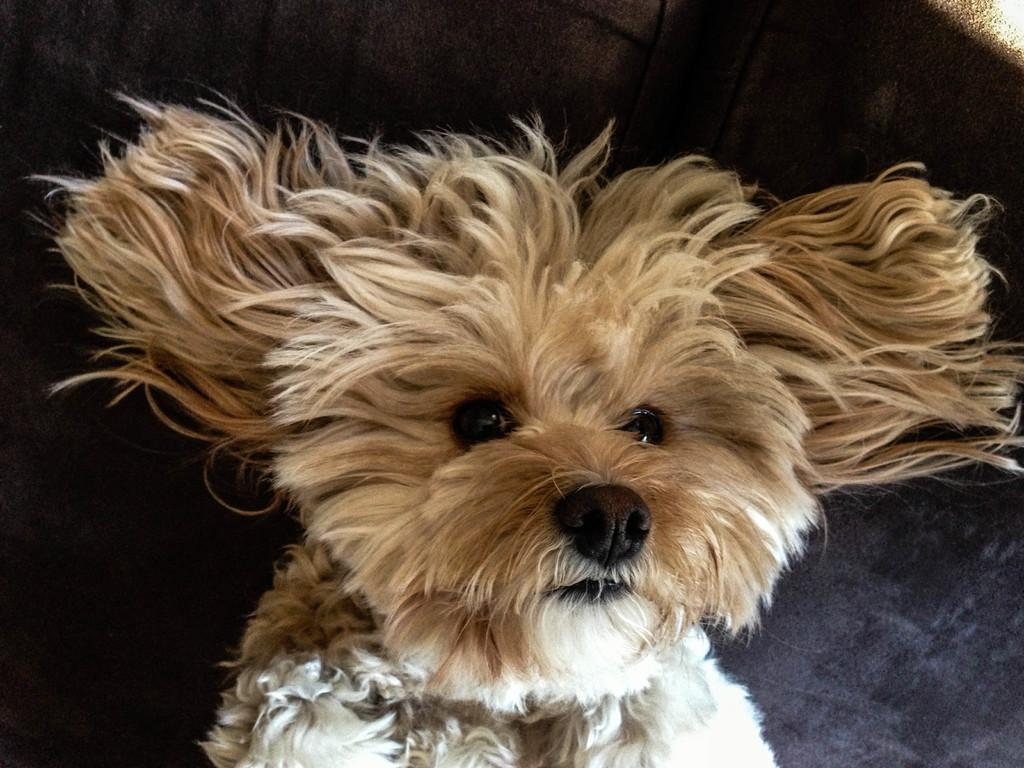What animal is present in the image? There is a dog in the picture. What color is the background of the image? The background of the image is black in color. Can you describe the grey area in the image? There is a grey area in the right bottom of the picture. What type of plough is being used in the protest depicted in the image? There is no plough or protest present in the image; it features a dog and a black background with a grey area. 